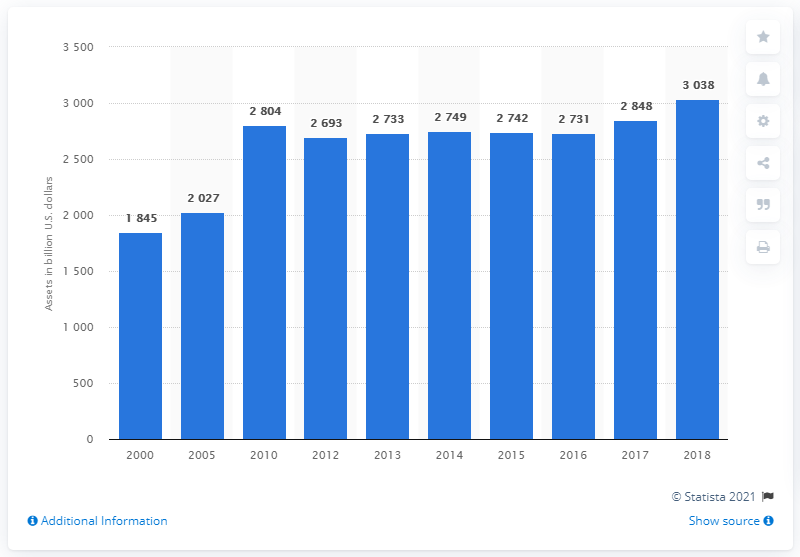Draw attention to some important aspects in this diagram. The financial assets of money market mutual funds in the United States in 2018 were approximately 3,038 billion dollars. 